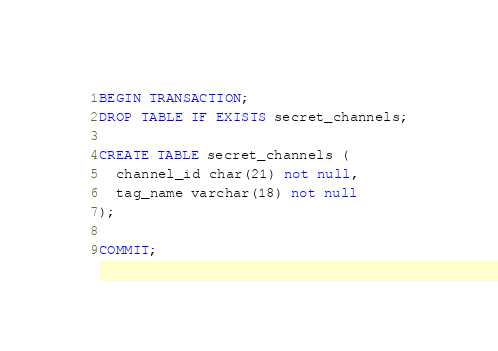Convert code to text. <code><loc_0><loc_0><loc_500><loc_500><_SQL_>BEGIN TRANSACTION;
DROP TABLE IF EXISTS secret_channels;

CREATE TABLE secret_channels (
  channel_id char(21) not null,
  tag_name varchar(18) not null
);

COMMIT;
</code> 